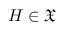Convert formula to latex. <formula><loc_0><loc_0><loc_500><loc_500>H \in { \mathfrak { X } }</formula> 